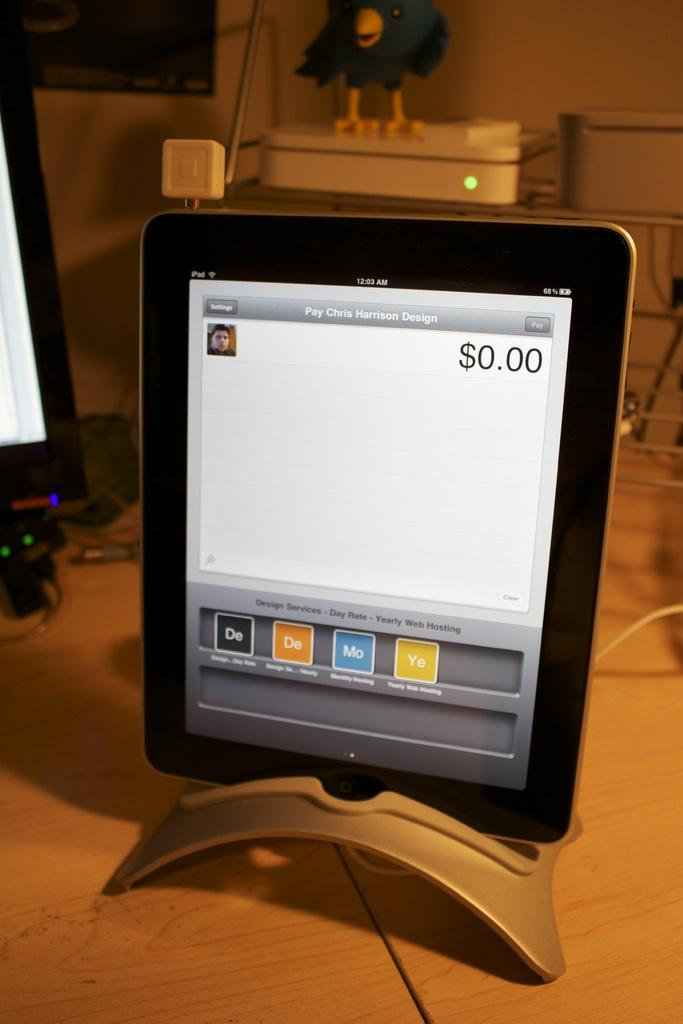<image>
Render a clear and concise summary of the photo. A tablet sitting on a desk that has Pay Chris Harrison Design on the screen. 